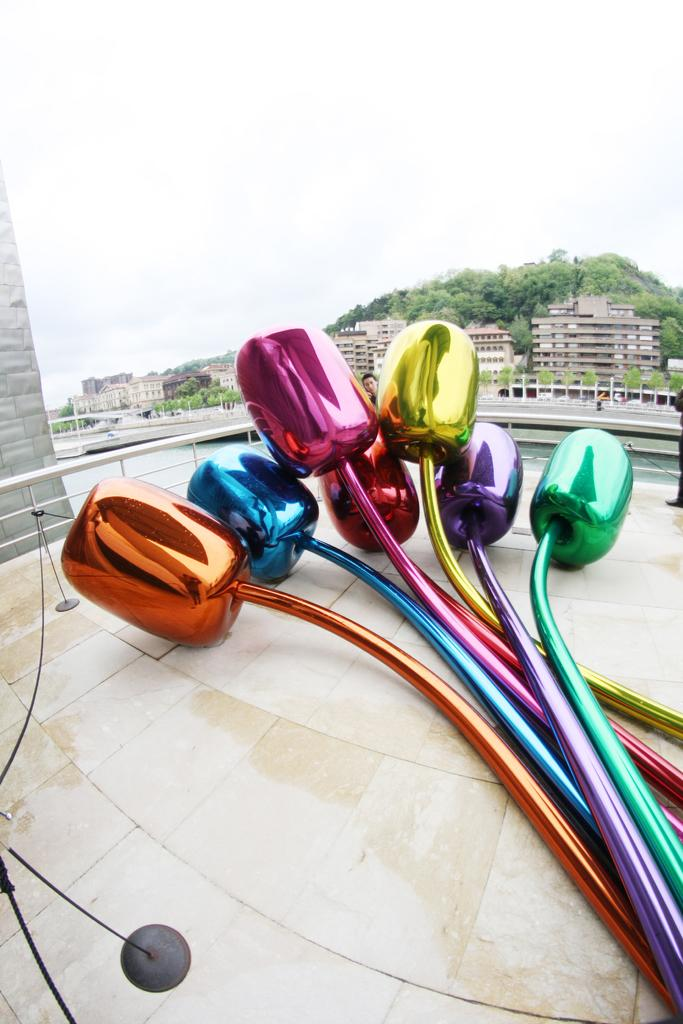What is placed on the floor in the image? There are show pieces on the floor. What is the relationship between the show pieces and the people in the image? There are people near the show pieces. What can be seen in the background of the image? There are metal rods, buildings, and trees visible in the background. What type of creature can be seen sniffing the show pieces in the image? There is no creature present in the image, and therefore no creature can be seen sniffing the show pieces. How many boys are visible in the image? There is no mention of boys in the provided facts, so we cannot determine the number of boys in the image. 